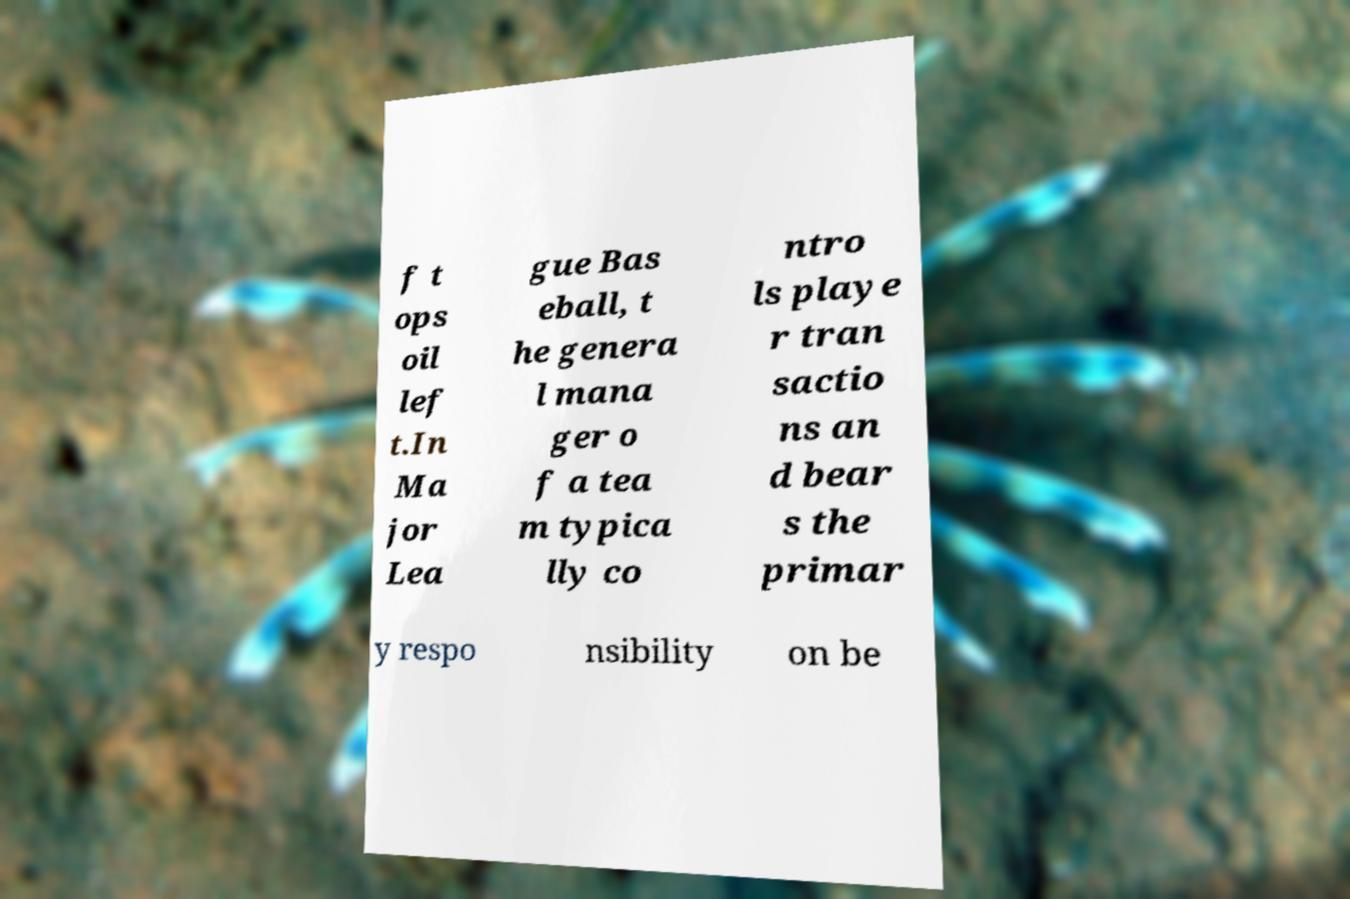Can you accurately transcribe the text from the provided image for me? f t ops oil lef t.In Ma jor Lea gue Bas eball, t he genera l mana ger o f a tea m typica lly co ntro ls playe r tran sactio ns an d bear s the primar y respo nsibility on be 